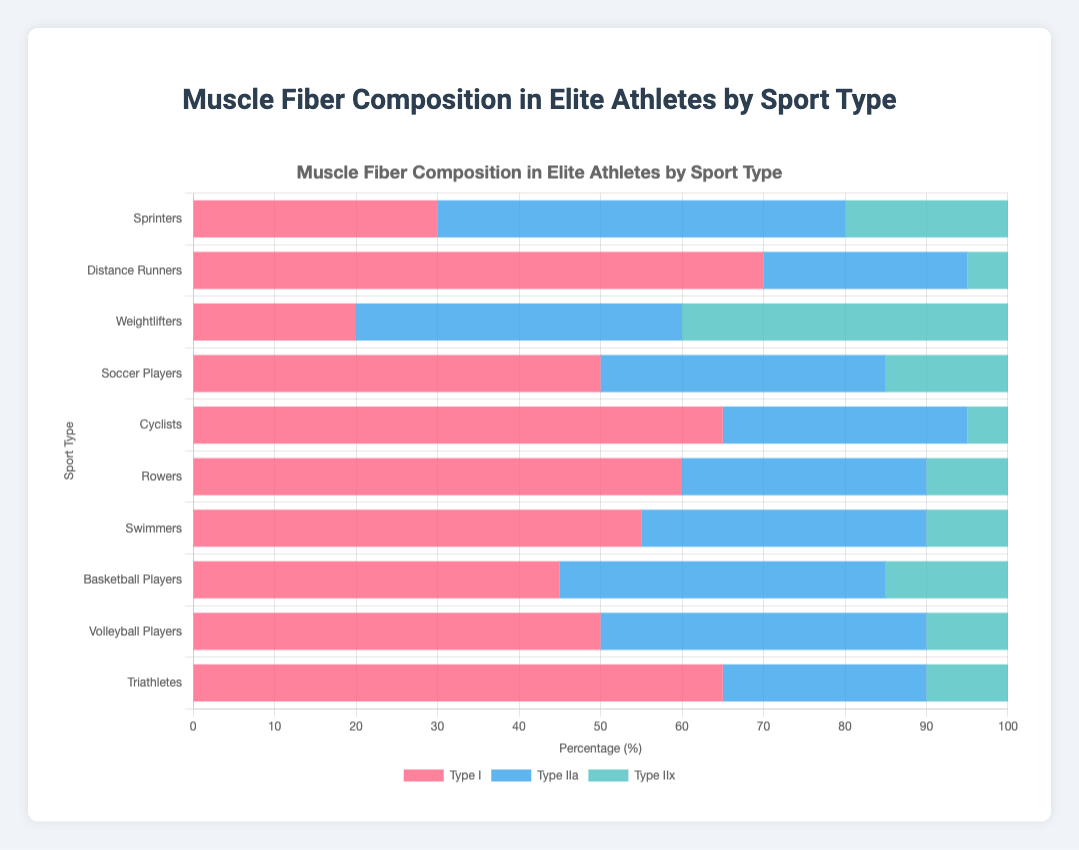What sport has the highest percentage of Type I muscle fibers? By examining the lengths of the segments corresponding to Type I muscle fibers (red bars), we see that Distance Runners have the longest, indicating the highest percentage at 70%.
Answer: Distance Runners Compare the composition of Type IIx muscle fibers between Weightlifters and Cyclists. We observe the blue segments representing Type IIx muscle fibers. Weightlifters have a larger blue segment (40%) compared to Cyclists (5%), indicating Weightlifters have a higher percentage of Type IIx muscle fibers.
Answer: Weightlifters have a higher percentage of Type IIx muscle fibers What is the combined percentage of Type II muscle fibers (IIa + IIx) in Soccer Players? Soccer players have 35% Type IIa (blue segment) and 15% Type IIx (blue segment). Adding these gives 35 + 15 = 50%.
Answer: 50% Which two sports have the exact same percentage of Type IIa muscle fibers? By examining the lengths of the blue segments representing Type IIa, Basketball Players and Volleyball Players both show a composition of 40% Type IIa fibers.
Answer: Basketball Players and Volleyball Players Which sport shows the most balanced composition of muscle fibers (i.e., with the least variability among the three types)? By visually comparing the lengths of the red, blue, and green segments for each sport, Sprinters show the most balanced composition with 30% Type I, 50% Type IIa, and 20% Type IIx, which are closest in values to each other.
Answer: Sprinters Among the listed sports, which one has the lowest percentage of Type IIx muscle fibers and what is that percentage? The smallest blue segment is observed for Distance Runners and Cyclists, both of which have 5% Type IIx fibers.
Answer: Distance Runners and Cyclists with 5% What's the percentage point difference of Type I muscle fibers between Volleyball Players and Weightlifters? Volleyball Players have 50% Type I fibers and Weightlifters have 20%. The difference is 50 - 20 = 30 percentage points.
Answer: 30 percentage points Which sport has a higher percentage of Type IIa fibers, Swimmers or Triathletes, and by how much? Swimmers have 35% Type IIa fibers, while Triathletes have 25%. The difference is 35 - 25 = 10 percentage points.
Answer: Swimmers by 10 percentage points Compare the distribution of Type I fibers between Cyclists and Swimmers. Which sport has a greater proportion and by how much? Cyclists have 65% Type I fibers, while Swimmers have 55%. The difference is 65 - 55 = 10 percentage points.
Answer: Cyclists by 10 percentage points What is the approximate visual length ratio of Type I to Type IIx fibers in Distance Runners? The red segment (Type I fibers) and blue segment (Type IIx fibers) for Distance Runners are 70% and 5%, respectively. The ratio is 70:5 which simplifies to 14:1.
Answer: 14:1 